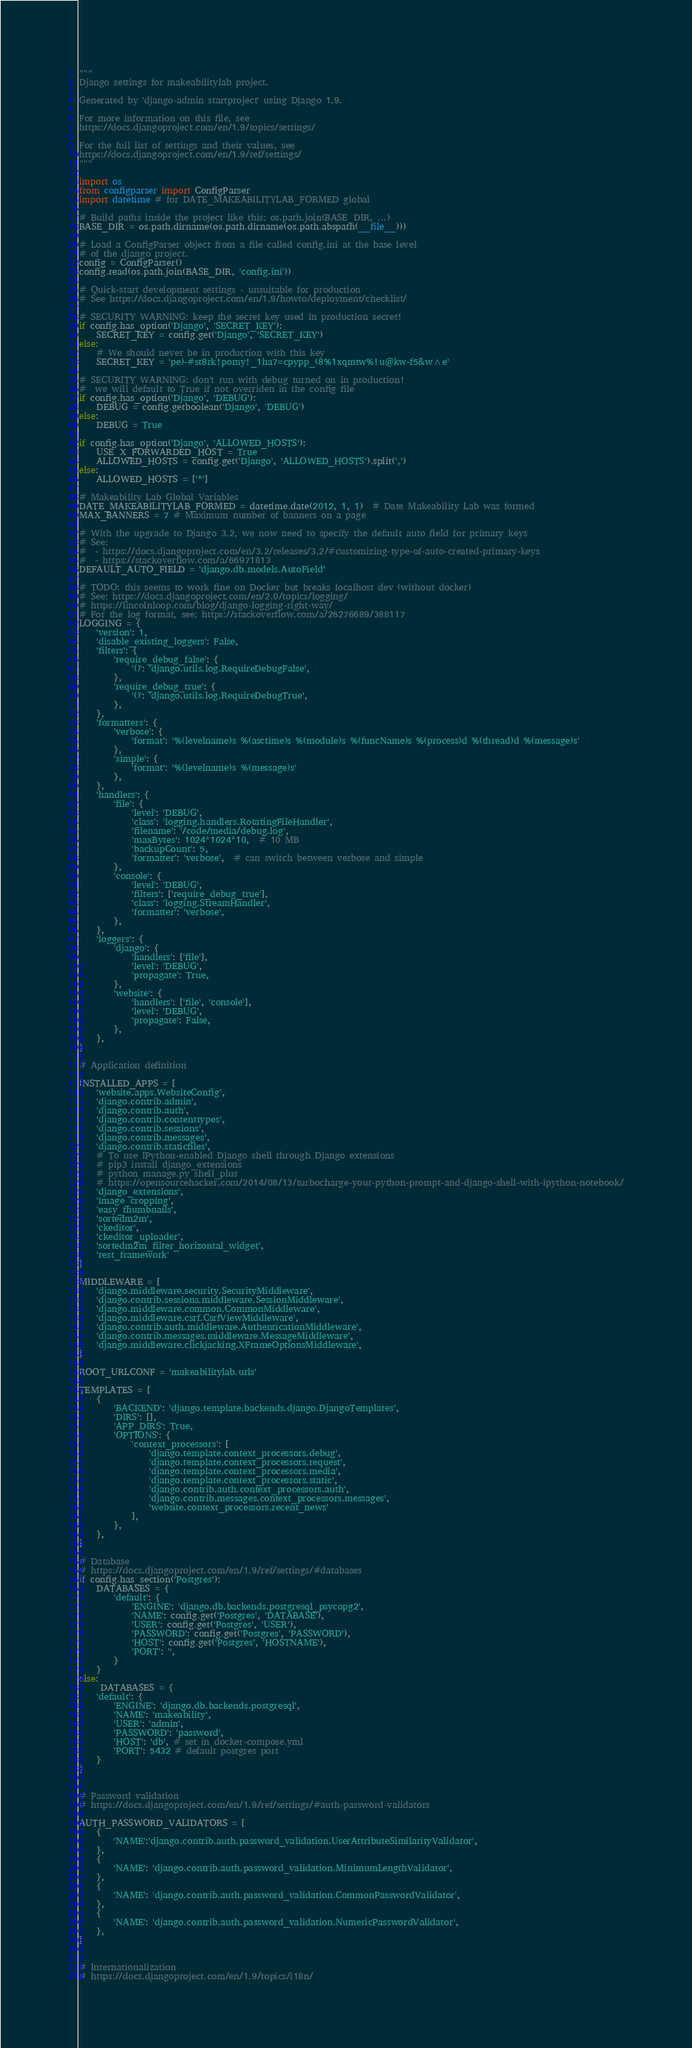<code> <loc_0><loc_0><loc_500><loc_500><_Python_>"""
Django settings for makeabilitylab project.

Generated by 'django-admin startproject' using Django 1.9.

For more information on this file, see
https://docs.djangoproject.com/en/1.9/topics/settings/

For the full list of settings and their values, see
https://docs.djangoproject.com/en/1.9/ref/settings/
"""

import os
from configparser import ConfigParser 
import datetime # for DATE_MAKEABILITYLAB_FORMED global

# Build paths inside the project like this: os.path.join(BASE_DIR, ...)
BASE_DIR = os.path.dirname(os.path.dirname(os.path.abspath(__file__)))

# Load a ConfigParser object from a file called config.ini at the base level
# of the django project.
config = ConfigParser()
config.read(os.path.join(BASE_DIR, 'config.ini'))

# Quick-start development settings - unsuitable for production
# See https://docs.djangoproject.com/en/1.9/howto/deployment/checklist/

# SECURITY WARNING: keep the secret key used in production secret!
if config.has_option('Django', 'SECRET_KEY'):
    SECRET_KEY = config.get('Django', 'SECRET_KEY')
else:
    # We should never be in production with this key
    SECRET_KEY = 'pe)-#st8rk!pomy!_1ha7=cpypp_(8%1xqmtw%!u@kw-f5&w^e' 

# SECURITY WARNING: don't run with debug turned on in production!
#  we will default to True if not overriden in the config file
if config.has_option('Django', 'DEBUG'):
    DEBUG = config.getboolean('Django', 'DEBUG')
else:
    DEBUG = True

if config.has_option('Django', 'ALLOWED_HOSTS'):
    USE_X_FORWARDED_HOST = True
    ALLOWED_HOSTS = config.get('Django', 'ALLOWED_HOSTS').split(',')
else:
    ALLOWED_HOSTS = ['*']

# Makeability Lab Global Variables
DATE_MAKEABILITYLAB_FORMED = datetime.date(2012, 1, 1)  # Date Makeability Lab was formed
MAX_BANNERS = 7 # Maximum number of banners on a page

# With the upgrade to Django 3.2, we now need to specify the default auto field for primary keys
# See: 
#  - https://docs.djangoproject.com/en/3.2/releases/3.2/#customizing-type-of-auto-created-primary-keys
#  - https://stackoverflow.com/a/66971813
DEFAULT_AUTO_FIELD = 'django.db.models.AutoField'

# TODO: this seems to work fine on Docker but breaks localhost dev (without docker)
# See: https://docs.djangoproject.com/en/2.0/topics/logging/
# https://lincolnloop.com/blog/django-logging-right-way/
# For the log format, see: https://stackoverflow.com/a/26276689/388117
LOGGING = {
    'version': 1,
    'disable_existing_loggers': False,
    'filters': {
        'require_debug_false': {
            '()': 'django.utils.log.RequireDebugFalse',
        },
        'require_debug_true': {
            '()': 'django.utils.log.RequireDebugTrue',
        },
    },
    'formatters': {
        'verbose': {
            'format': '%(levelname)s %(asctime)s %(module)s %(funcName)s %(process)d %(thread)d %(message)s'
        },
        'simple': {
            'format': '%(levelname)s %(message)s'
        },
    },
    'handlers': {
        'file': {
            'level': 'DEBUG',
            'class': 'logging.handlers.RotatingFileHandler',
            'filename': '/code/media/debug.log',
            'maxBytes': 1024*1024*10,  # 10 MB
            'backupCount': 5,
            'formatter': 'verbose',  # can switch between verbose and simple
        },
        'console': {
            'level': 'DEBUG',
            'filters': ['require_debug_true'],
            'class': 'logging.StreamHandler',
            'formatter': 'verbose',
        },
    },
    'loggers': {
        'django': {
            'handlers': ['file'],
            'level': 'DEBUG',
            'propagate': True,
        },
        'website': {
            'handlers': ['file', 'console'],
            'level': 'DEBUG',
            'propagate': False,
        },
    },
}

# Application definition

INSTALLED_APPS = [
    'website.apps.WebsiteConfig',
    'django.contrib.admin',
    'django.contrib.auth',
    'django.contrib.contenttypes',
    'django.contrib.sessions',
    'django.contrib.messages',
    'django.contrib.staticfiles',
    # To use IPython-enabled Django shell through Django extensions
    # pip3 install django_extensions
    # python manage.py shell_plus
    # https://opensourcehacker.com/2014/08/13/turbocharge-your-python-prompt-and-django-shell-with-ipython-notebook/
    'django_extensions',
    'image_cropping',
    'easy_thumbnails',
    'sortedm2m',
    'ckeditor',
    'ckeditor_uploader',
    'sortedm2m_filter_horizontal_widget',
    'rest_framework'
]

MIDDLEWARE = [
    'django.middleware.security.SecurityMiddleware',
    'django.contrib.sessions.middleware.SessionMiddleware',
    'django.middleware.common.CommonMiddleware',
    'django.middleware.csrf.CsrfViewMiddleware',
    'django.contrib.auth.middleware.AuthenticationMiddleware',
    'django.contrib.messages.middleware.MessageMiddleware',
    'django.middleware.clickjacking.XFrameOptionsMiddleware',
]

ROOT_URLCONF = 'makeabilitylab.urls'

TEMPLATES = [
    {
        'BACKEND': 'django.template.backends.django.DjangoTemplates',
        'DIRS': [],
        'APP_DIRS': True,
        'OPTIONS': {
            'context_processors': [
                'django.template.context_processors.debug',
                'django.template.context_processors.request',
                'django.template.context_processors.media',
                'django.template.context_processors.static',
                'django.contrib.auth.context_processors.auth',
                'django.contrib.messages.context_processors.messages',
                'website.context_processors.recent_news'
            ],
        },
    },
]

# Database
# https://docs.djangoproject.com/en/1.9/ref/settings/#databases
if config.has_section('Postgres'):
    DATABASES = {
        'default': {
            'ENGINE': 'django.db.backends.postgresql_psycopg2',
            'NAME': config.get('Postgres', 'DATABASE'),
            'USER': config.get('Postgres', 'USER'),
            'PASSWORD': config.get('Postgres', 'PASSWORD'),
            'HOST': config.get('Postgres', 'HOSTNAME'),
            'PORT': '',
        }
    }
else:
     DATABASES = {
    'default': {
        'ENGINE': 'django.db.backends.postgresql',
        'NAME': 'makeability',
        'USER': 'admin',
        'PASSWORD': 'password',
        'HOST': 'db', # set in docker-compose.yml
        'PORT': 5432 # default postgres port
    }
}


# Password validation
# https://docs.djangoproject.com/en/1.9/ref/settings/#auth-password-validators

AUTH_PASSWORD_VALIDATORS = [
    {
        'NAME':'django.contrib.auth.password_validation.UserAttributeSimilarityValidator',
    },
    {
        'NAME': 'django.contrib.auth.password_validation.MinimumLengthValidator',
    },
    {
        'NAME': 'django.contrib.auth.password_validation.CommonPasswordValidator',
    },
    {
        'NAME': 'django.contrib.auth.password_validation.NumericPasswordValidator',
    },
]


# Internationalization
# https://docs.djangoproject.com/en/1.9/topics/i18n/
</code> 